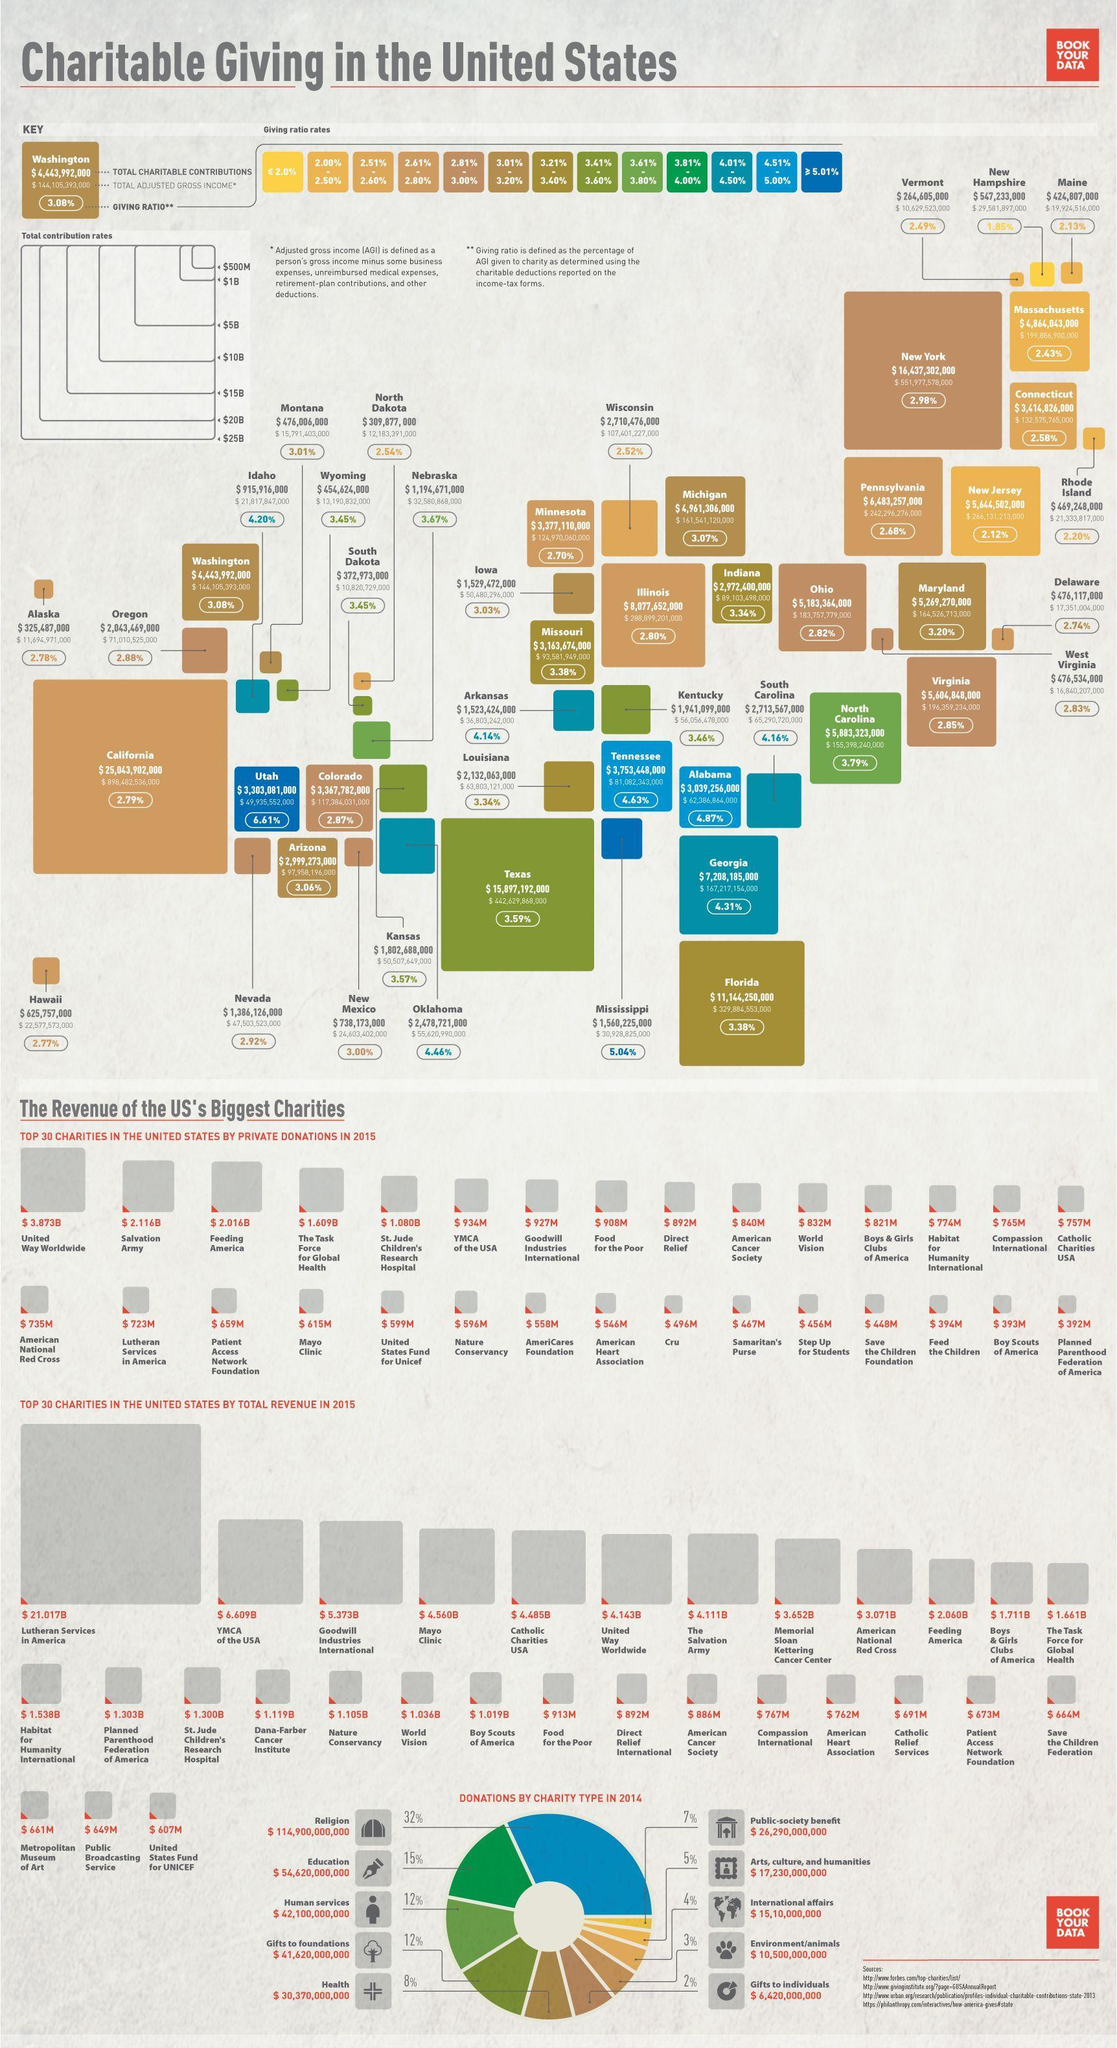What is the revenue of charity Organisation "Boy Scouts of America"?
Answer the question with a short phrase. $ 393M What is the total adjusted Gross Income of California? $ 898,482,536,000 What is the second highest total revenue of charity Organisations in 2015? $ 6.609B What is the total adjusted Gross Income of Maine? $ 19,924,516,000 What is the amount of Total Charitable contributions from the state Vermont? $ 264,605,000 Which charity organisation has the second lowest total revenue in 2015? Public Broadcasting Service How many charity types are shown in the info graphic? 10 What is the revenue of Organisation "Salvation Army"? $ 2.116B What is the amount of Total Charitable contributions from the state New Hampshire? $ 547,233,000 How much is the amount of Donation from Public-society benefit? $ 26,290,000,000 